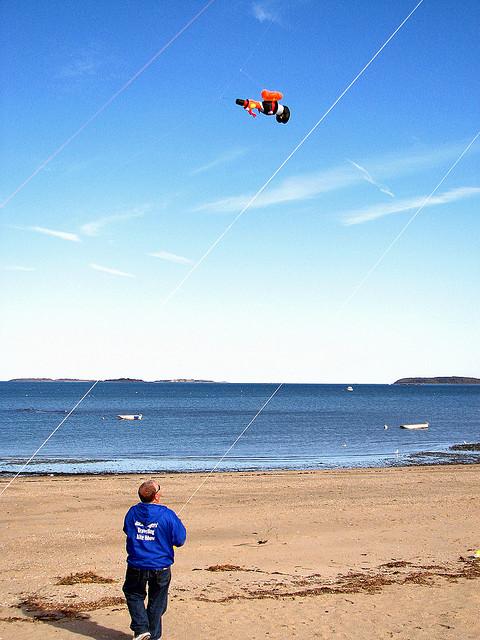Is it a hot day in this picture?
Quick response, please. No. Is the person male or female?
Concise answer only. Male. What is attached to the string that the man is holding on to?
Keep it brief. Kite. 